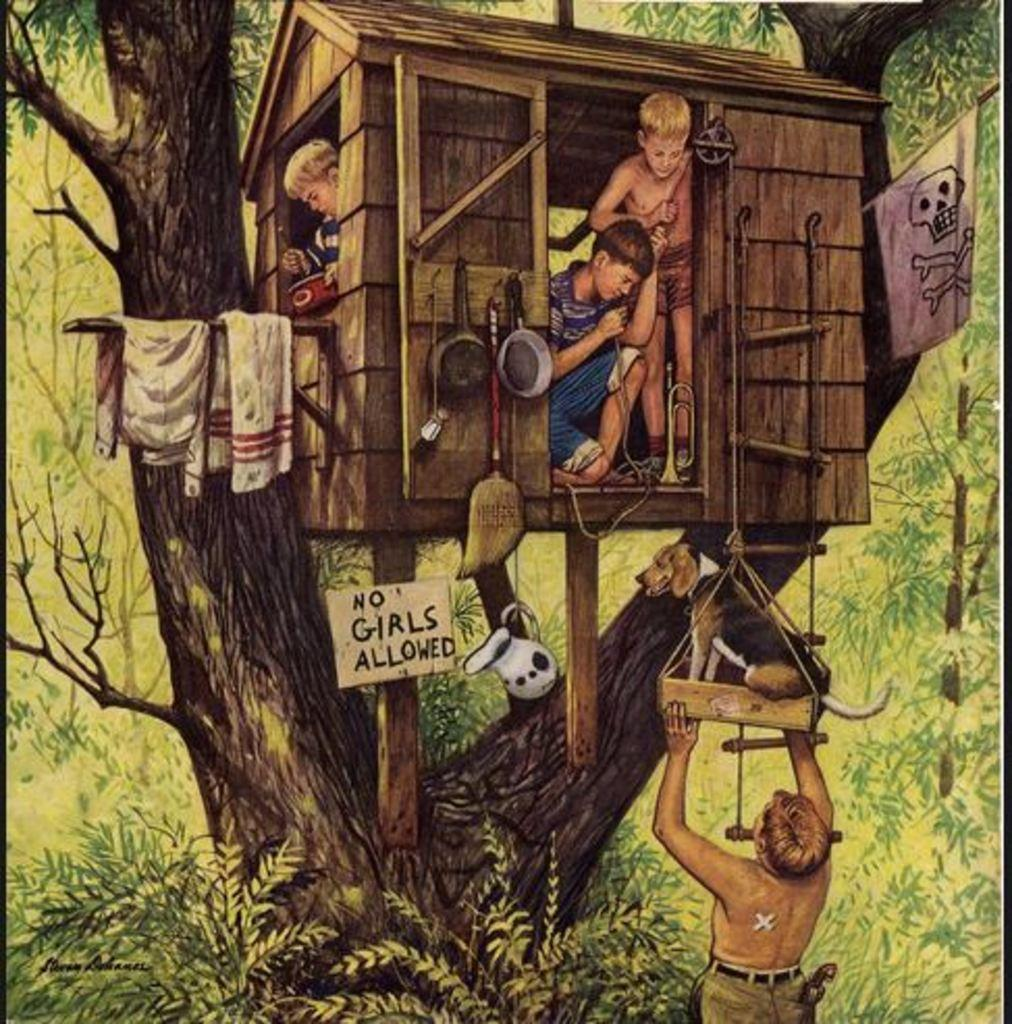What is depicted in the painting in the image? There is a painting of boys in the image. Where is the painting located? The painting is in a hut. What can be seen near the hut? There is a flag near the hut. What is visible behind the hut? There are trees behind the hut. Can you tell me how many goldfish are swimming in the hut in the image? There are no goldfish present in the image; the painting depicts boys, and the hut is the location of the painting. 